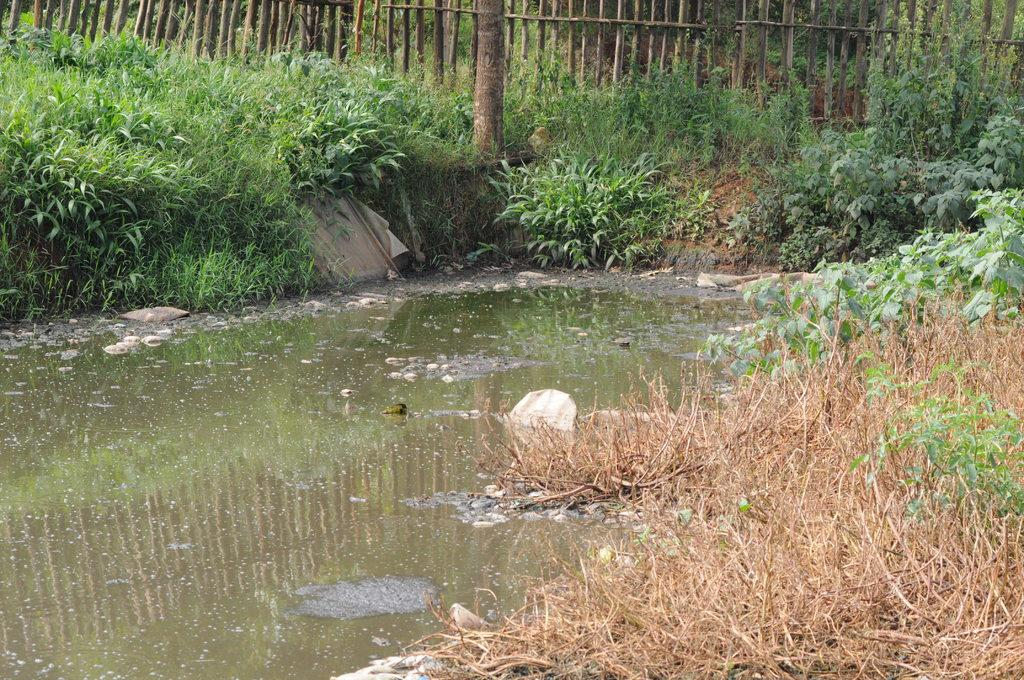What is one of the main elements in the image? There is water in the image. What other objects or features can be seen in the image? There are stones, dried grass, plants, the bark of a tree, and a wooden fence in the image. Can you describe the vegetation in the image? Plants are visible in the image. What type of material is the fence made of? The wooden fence in the image is made of wood. How many people are in the crowd in the image? There is no crowd present in the image; it features natural elements such as water, stones, dried grass, plants, the bark of a tree, and a wooden fence. What sound does the whistle make in the image? There is no whistle present in the image. 